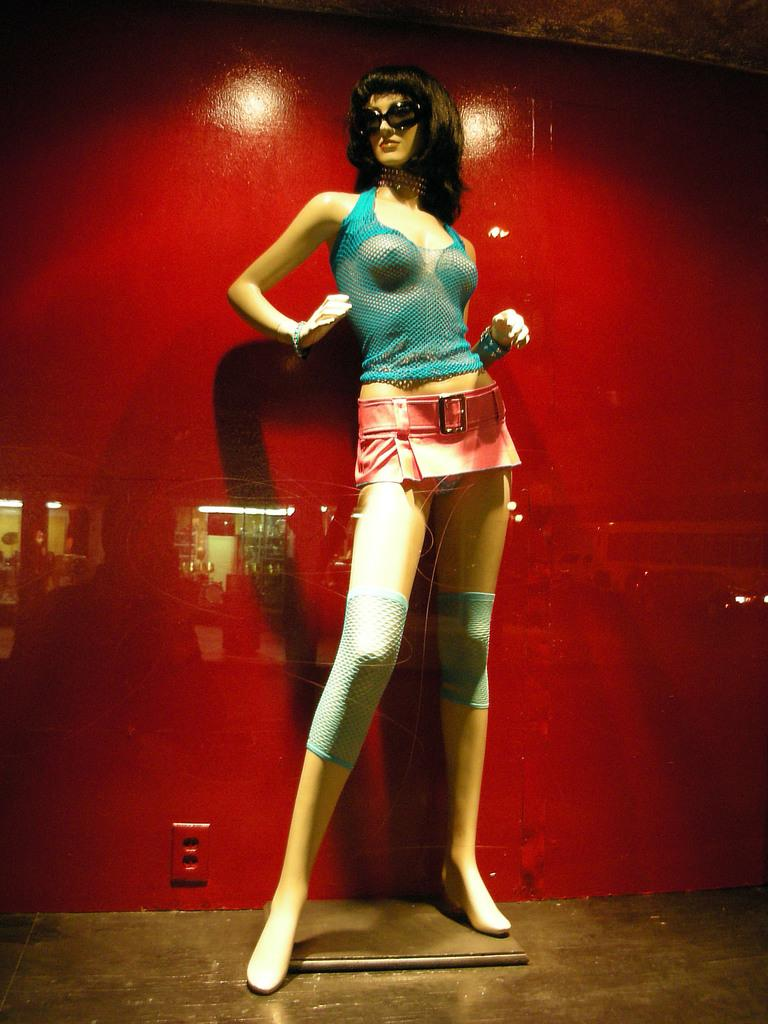What is the main subject of the image? The main subject of the image is a statue of a woman. What is the woman wearing on her face? The woman is wearing goggles. What type of clothing is the woman wearing on her upper body? The woman is wearing a t-shirt. What type of clothing is the woman wearing on her lower body? The woman is wearing shorts. What type of clothing is the woman wearing around her waist? The woman is wearing a cloth around her waist. What can be seen in the background of the image? There is a red color wall in the background of the image. Can you tell me how deep the river is in the image? There is no river present in the image; it features a statue of a woman with a red color wall in the background. What type of class is being held in the image? There is no class or any indication of a class being held in the image. 